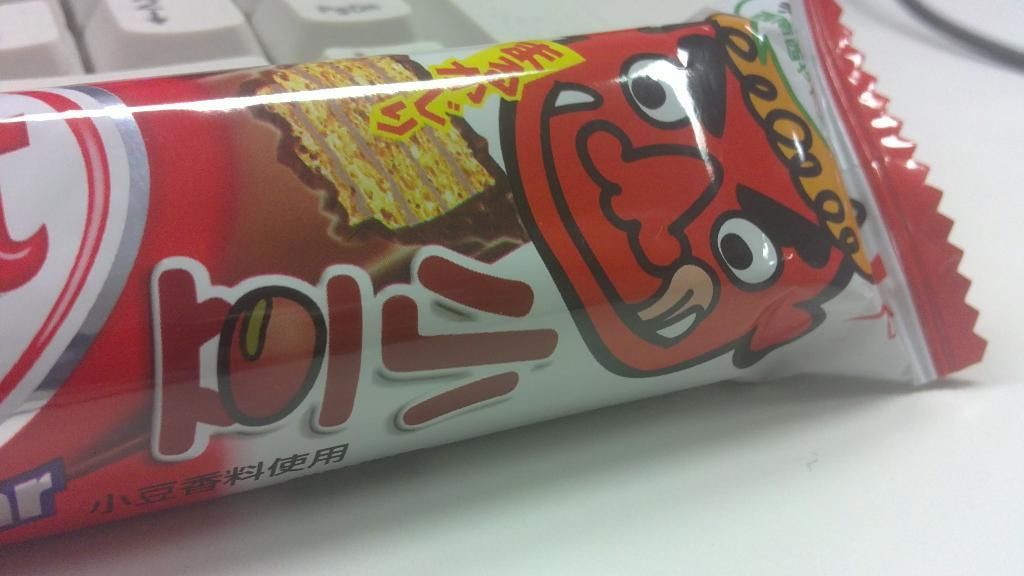What is the main object in the center of the image? There is a wrapper in the center of the image. Where is the wrapper placed? The wrapper is placed on a table. What can be seen in the background of the image? There is a keyboard visible in the background of the image. What type of underwear is visible on the keyboard in the image? There is no underwear present in the image, and the keyboard is not associated with any clothing items. 